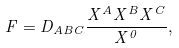Convert formula to latex. <formula><loc_0><loc_0><loc_500><loc_500>F = D _ { A B C } \frac { X ^ { A } X ^ { B } X ^ { C } } { X ^ { 0 } } ,</formula> 